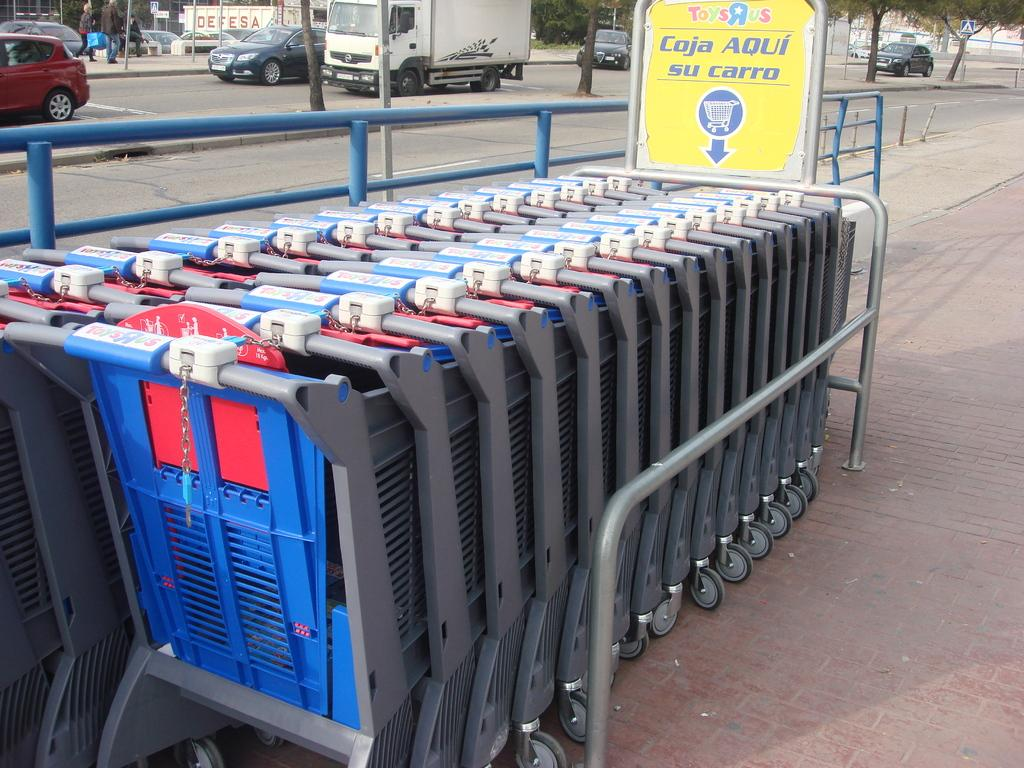What is located in the center of the image? There are trolleys, boards, and railing in the center of the image. What can be seen in the background of the image? There are trees, vehicles, and persons in the background of the image. What is at the bottom of the image? There is a road at the bottom of the image. How many calculators are visible on the trolleys in the image? There are no calculators present in the image; it features trolleys, boards, and railing in the center. What type of spring is shown supporting the railing in the image? There is no spring present in the image; it features railing, trolleys, and boards in the center. 